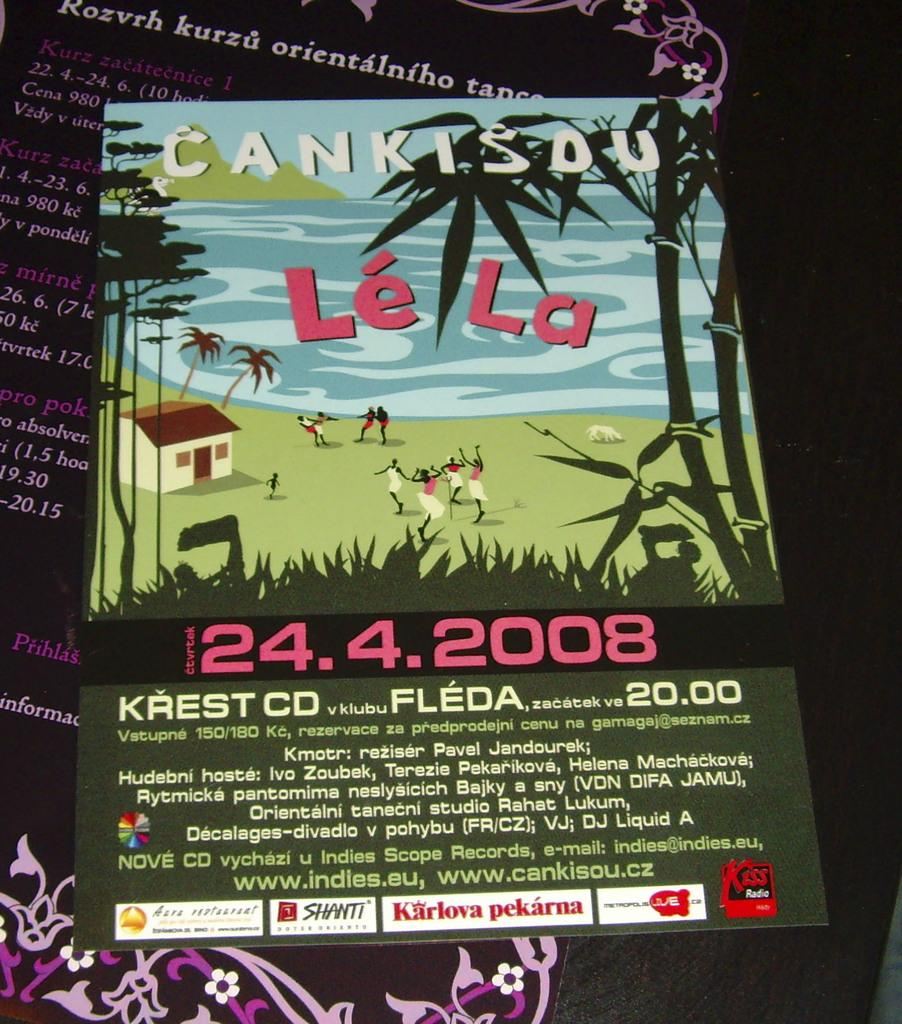Provide a one-sentence caption for the provided image. Cankisdu Le La Music Festival on April 24th, 2008. 